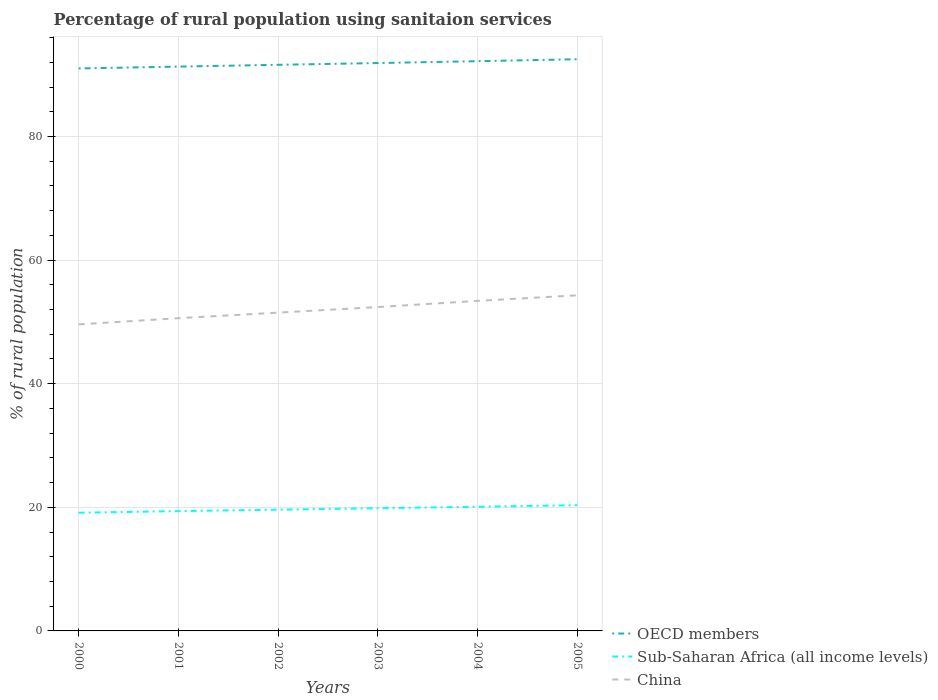How many different coloured lines are there?
Make the answer very short. 3. Does the line corresponding to Sub-Saharan Africa (all income levels) intersect with the line corresponding to OECD members?
Your answer should be very brief. No. Is the number of lines equal to the number of legend labels?
Offer a very short reply. Yes. Across all years, what is the maximum percentage of rural population using sanitaion services in OECD members?
Offer a terse response. 91.01. What is the total percentage of rural population using sanitaion services in OECD members in the graph?
Offer a terse response. -1.19. What is the difference between the highest and the second highest percentage of rural population using sanitaion services in OECD members?
Give a very brief answer. 1.48. What is the difference between the highest and the lowest percentage of rural population using sanitaion services in China?
Give a very brief answer. 3. Is the percentage of rural population using sanitaion services in OECD members strictly greater than the percentage of rural population using sanitaion services in Sub-Saharan Africa (all income levels) over the years?
Your answer should be very brief. No. How many lines are there?
Ensure brevity in your answer.  3. How many years are there in the graph?
Keep it short and to the point. 6. Are the values on the major ticks of Y-axis written in scientific E-notation?
Provide a succinct answer. No. How many legend labels are there?
Provide a succinct answer. 3. What is the title of the graph?
Offer a very short reply. Percentage of rural population using sanitaion services. Does "French Polynesia" appear as one of the legend labels in the graph?
Keep it short and to the point. No. What is the label or title of the Y-axis?
Your response must be concise. % of rural population. What is the % of rural population of OECD members in 2000?
Offer a terse response. 91.01. What is the % of rural population in Sub-Saharan Africa (all income levels) in 2000?
Provide a succinct answer. 19.13. What is the % of rural population of China in 2000?
Your answer should be very brief. 49.6. What is the % of rural population in OECD members in 2001?
Your response must be concise. 91.3. What is the % of rural population of Sub-Saharan Africa (all income levels) in 2001?
Keep it short and to the point. 19.38. What is the % of rural population of China in 2001?
Make the answer very short. 50.6. What is the % of rural population in OECD members in 2002?
Your answer should be compact. 91.6. What is the % of rural population in Sub-Saharan Africa (all income levels) in 2002?
Your answer should be compact. 19.62. What is the % of rural population in China in 2002?
Provide a short and direct response. 51.5. What is the % of rural population of OECD members in 2003?
Offer a very short reply. 91.88. What is the % of rural population of Sub-Saharan Africa (all income levels) in 2003?
Ensure brevity in your answer.  19.85. What is the % of rural population of China in 2003?
Give a very brief answer. 52.4. What is the % of rural population of OECD members in 2004?
Give a very brief answer. 92.18. What is the % of rural population of Sub-Saharan Africa (all income levels) in 2004?
Keep it short and to the point. 20.09. What is the % of rural population in China in 2004?
Give a very brief answer. 53.4. What is the % of rural population of OECD members in 2005?
Give a very brief answer. 92.5. What is the % of rural population of Sub-Saharan Africa (all income levels) in 2005?
Keep it short and to the point. 20.35. What is the % of rural population in China in 2005?
Keep it short and to the point. 54.3. Across all years, what is the maximum % of rural population in OECD members?
Give a very brief answer. 92.5. Across all years, what is the maximum % of rural population of Sub-Saharan Africa (all income levels)?
Give a very brief answer. 20.35. Across all years, what is the maximum % of rural population of China?
Offer a terse response. 54.3. Across all years, what is the minimum % of rural population in OECD members?
Provide a succinct answer. 91.01. Across all years, what is the minimum % of rural population in Sub-Saharan Africa (all income levels)?
Your answer should be compact. 19.13. Across all years, what is the minimum % of rural population in China?
Ensure brevity in your answer.  49.6. What is the total % of rural population in OECD members in the graph?
Provide a succinct answer. 550.47. What is the total % of rural population of Sub-Saharan Africa (all income levels) in the graph?
Make the answer very short. 118.42. What is the total % of rural population of China in the graph?
Your answer should be compact. 311.8. What is the difference between the % of rural population in OECD members in 2000 and that in 2001?
Your response must be concise. -0.29. What is the difference between the % of rural population in Sub-Saharan Africa (all income levels) in 2000 and that in 2001?
Ensure brevity in your answer.  -0.26. What is the difference between the % of rural population of China in 2000 and that in 2001?
Offer a very short reply. -1. What is the difference between the % of rural population of OECD members in 2000 and that in 2002?
Provide a succinct answer. -0.59. What is the difference between the % of rural population in Sub-Saharan Africa (all income levels) in 2000 and that in 2002?
Offer a very short reply. -0.49. What is the difference between the % of rural population in OECD members in 2000 and that in 2003?
Provide a succinct answer. -0.87. What is the difference between the % of rural population of Sub-Saharan Africa (all income levels) in 2000 and that in 2003?
Your answer should be compact. -0.72. What is the difference between the % of rural population of OECD members in 2000 and that in 2004?
Your answer should be compact. -1.17. What is the difference between the % of rural population in Sub-Saharan Africa (all income levels) in 2000 and that in 2004?
Give a very brief answer. -0.96. What is the difference between the % of rural population of OECD members in 2000 and that in 2005?
Ensure brevity in your answer.  -1.48. What is the difference between the % of rural population in Sub-Saharan Africa (all income levels) in 2000 and that in 2005?
Your response must be concise. -1.22. What is the difference between the % of rural population in OECD members in 2001 and that in 2002?
Ensure brevity in your answer.  -0.29. What is the difference between the % of rural population of Sub-Saharan Africa (all income levels) in 2001 and that in 2002?
Your response must be concise. -0.23. What is the difference between the % of rural population of China in 2001 and that in 2002?
Your answer should be very brief. -0.9. What is the difference between the % of rural population in OECD members in 2001 and that in 2003?
Offer a very short reply. -0.58. What is the difference between the % of rural population in Sub-Saharan Africa (all income levels) in 2001 and that in 2003?
Give a very brief answer. -0.47. What is the difference between the % of rural population of China in 2001 and that in 2003?
Your answer should be compact. -1.8. What is the difference between the % of rural population in OECD members in 2001 and that in 2004?
Offer a very short reply. -0.88. What is the difference between the % of rural population in Sub-Saharan Africa (all income levels) in 2001 and that in 2004?
Make the answer very short. -0.71. What is the difference between the % of rural population in China in 2001 and that in 2004?
Provide a short and direct response. -2.8. What is the difference between the % of rural population in OECD members in 2001 and that in 2005?
Your answer should be very brief. -1.19. What is the difference between the % of rural population in Sub-Saharan Africa (all income levels) in 2001 and that in 2005?
Offer a terse response. -0.96. What is the difference between the % of rural population of OECD members in 2002 and that in 2003?
Offer a very short reply. -0.28. What is the difference between the % of rural population of Sub-Saharan Africa (all income levels) in 2002 and that in 2003?
Provide a succinct answer. -0.23. What is the difference between the % of rural population in China in 2002 and that in 2003?
Your answer should be compact. -0.9. What is the difference between the % of rural population in OECD members in 2002 and that in 2004?
Your response must be concise. -0.58. What is the difference between the % of rural population of Sub-Saharan Africa (all income levels) in 2002 and that in 2004?
Your answer should be very brief. -0.47. What is the difference between the % of rural population of China in 2002 and that in 2004?
Your answer should be very brief. -1.9. What is the difference between the % of rural population in OECD members in 2002 and that in 2005?
Make the answer very short. -0.9. What is the difference between the % of rural population of Sub-Saharan Africa (all income levels) in 2002 and that in 2005?
Provide a short and direct response. -0.73. What is the difference between the % of rural population of OECD members in 2003 and that in 2004?
Your answer should be very brief. -0.3. What is the difference between the % of rural population in Sub-Saharan Africa (all income levels) in 2003 and that in 2004?
Provide a short and direct response. -0.24. What is the difference between the % of rural population in OECD members in 2003 and that in 2005?
Make the answer very short. -0.62. What is the difference between the % of rural population of Sub-Saharan Africa (all income levels) in 2003 and that in 2005?
Provide a succinct answer. -0.5. What is the difference between the % of rural population of OECD members in 2004 and that in 2005?
Your answer should be compact. -0.32. What is the difference between the % of rural population of Sub-Saharan Africa (all income levels) in 2004 and that in 2005?
Offer a terse response. -0.25. What is the difference between the % of rural population in China in 2004 and that in 2005?
Your response must be concise. -0.9. What is the difference between the % of rural population in OECD members in 2000 and the % of rural population in Sub-Saharan Africa (all income levels) in 2001?
Your answer should be compact. 71.63. What is the difference between the % of rural population in OECD members in 2000 and the % of rural population in China in 2001?
Ensure brevity in your answer.  40.41. What is the difference between the % of rural population in Sub-Saharan Africa (all income levels) in 2000 and the % of rural population in China in 2001?
Make the answer very short. -31.47. What is the difference between the % of rural population in OECD members in 2000 and the % of rural population in Sub-Saharan Africa (all income levels) in 2002?
Make the answer very short. 71.39. What is the difference between the % of rural population in OECD members in 2000 and the % of rural population in China in 2002?
Provide a short and direct response. 39.51. What is the difference between the % of rural population in Sub-Saharan Africa (all income levels) in 2000 and the % of rural population in China in 2002?
Ensure brevity in your answer.  -32.37. What is the difference between the % of rural population in OECD members in 2000 and the % of rural population in Sub-Saharan Africa (all income levels) in 2003?
Your response must be concise. 71.16. What is the difference between the % of rural population in OECD members in 2000 and the % of rural population in China in 2003?
Ensure brevity in your answer.  38.61. What is the difference between the % of rural population in Sub-Saharan Africa (all income levels) in 2000 and the % of rural population in China in 2003?
Provide a succinct answer. -33.27. What is the difference between the % of rural population of OECD members in 2000 and the % of rural population of Sub-Saharan Africa (all income levels) in 2004?
Ensure brevity in your answer.  70.92. What is the difference between the % of rural population in OECD members in 2000 and the % of rural population in China in 2004?
Your answer should be compact. 37.61. What is the difference between the % of rural population in Sub-Saharan Africa (all income levels) in 2000 and the % of rural population in China in 2004?
Your response must be concise. -34.27. What is the difference between the % of rural population of OECD members in 2000 and the % of rural population of Sub-Saharan Africa (all income levels) in 2005?
Offer a very short reply. 70.66. What is the difference between the % of rural population of OECD members in 2000 and the % of rural population of China in 2005?
Make the answer very short. 36.71. What is the difference between the % of rural population of Sub-Saharan Africa (all income levels) in 2000 and the % of rural population of China in 2005?
Give a very brief answer. -35.17. What is the difference between the % of rural population of OECD members in 2001 and the % of rural population of Sub-Saharan Africa (all income levels) in 2002?
Ensure brevity in your answer.  71.69. What is the difference between the % of rural population of OECD members in 2001 and the % of rural population of China in 2002?
Make the answer very short. 39.8. What is the difference between the % of rural population of Sub-Saharan Africa (all income levels) in 2001 and the % of rural population of China in 2002?
Offer a very short reply. -32.12. What is the difference between the % of rural population in OECD members in 2001 and the % of rural population in Sub-Saharan Africa (all income levels) in 2003?
Your response must be concise. 71.45. What is the difference between the % of rural population in OECD members in 2001 and the % of rural population in China in 2003?
Ensure brevity in your answer.  38.9. What is the difference between the % of rural population in Sub-Saharan Africa (all income levels) in 2001 and the % of rural population in China in 2003?
Ensure brevity in your answer.  -33.02. What is the difference between the % of rural population of OECD members in 2001 and the % of rural population of Sub-Saharan Africa (all income levels) in 2004?
Make the answer very short. 71.21. What is the difference between the % of rural population in OECD members in 2001 and the % of rural population in China in 2004?
Ensure brevity in your answer.  37.9. What is the difference between the % of rural population in Sub-Saharan Africa (all income levels) in 2001 and the % of rural population in China in 2004?
Give a very brief answer. -34.02. What is the difference between the % of rural population in OECD members in 2001 and the % of rural population in Sub-Saharan Africa (all income levels) in 2005?
Keep it short and to the point. 70.96. What is the difference between the % of rural population in OECD members in 2001 and the % of rural population in China in 2005?
Your answer should be very brief. 37. What is the difference between the % of rural population of Sub-Saharan Africa (all income levels) in 2001 and the % of rural population of China in 2005?
Make the answer very short. -34.92. What is the difference between the % of rural population of OECD members in 2002 and the % of rural population of Sub-Saharan Africa (all income levels) in 2003?
Offer a terse response. 71.75. What is the difference between the % of rural population in OECD members in 2002 and the % of rural population in China in 2003?
Offer a very short reply. 39.2. What is the difference between the % of rural population of Sub-Saharan Africa (all income levels) in 2002 and the % of rural population of China in 2003?
Provide a short and direct response. -32.78. What is the difference between the % of rural population in OECD members in 2002 and the % of rural population in Sub-Saharan Africa (all income levels) in 2004?
Give a very brief answer. 71.51. What is the difference between the % of rural population of OECD members in 2002 and the % of rural population of China in 2004?
Make the answer very short. 38.2. What is the difference between the % of rural population of Sub-Saharan Africa (all income levels) in 2002 and the % of rural population of China in 2004?
Give a very brief answer. -33.78. What is the difference between the % of rural population of OECD members in 2002 and the % of rural population of Sub-Saharan Africa (all income levels) in 2005?
Offer a very short reply. 71.25. What is the difference between the % of rural population of OECD members in 2002 and the % of rural population of China in 2005?
Ensure brevity in your answer.  37.3. What is the difference between the % of rural population of Sub-Saharan Africa (all income levels) in 2002 and the % of rural population of China in 2005?
Make the answer very short. -34.68. What is the difference between the % of rural population of OECD members in 2003 and the % of rural population of Sub-Saharan Africa (all income levels) in 2004?
Offer a very short reply. 71.79. What is the difference between the % of rural population of OECD members in 2003 and the % of rural population of China in 2004?
Your answer should be very brief. 38.48. What is the difference between the % of rural population of Sub-Saharan Africa (all income levels) in 2003 and the % of rural population of China in 2004?
Your answer should be very brief. -33.55. What is the difference between the % of rural population in OECD members in 2003 and the % of rural population in Sub-Saharan Africa (all income levels) in 2005?
Your answer should be compact. 71.53. What is the difference between the % of rural population in OECD members in 2003 and the % of rural population in China in 2005?
Give a very brief answer. 37.58. What is the difference between the % of rural population in Sub-Saharan Africa (all income levels) in 2003 and the % of rural population in China in 2005?
Make the answer very short. -34.45. What is the difference between the % of rural population in OECD members in 2004 and the % of rural population in Sub-Saharan Africa (all income levels) in 2005?
Provide a short and direct response. 71.83. What is the difference between the % of rural population in OECD members in 2004 and the % of rural population in China in 2005?
Provide a short and direct response. 37.88. What is the difference between the % of rural population in Sub-Saharan Africa (all income levels) in 2004 and the % of rural population in China in 2005?
Offer a very short reply. -34.21. What is the average % of rural population in OECD members per year?
Provide a succinct answer. 91.74. What is the average % of rural population of Sub-Saharan Africa (all income levels) per year?
Your answer should be very brief. 19.74. What is the average % of rural population in China per year?
Keep it short and to the point. 51.97. In the year 2000, what is the difference between the % of rural population in OECD members and % of rural population in Sub-Saharan Africa (all income levels)?
Provide a succinct answer. 71.88. In the year 2000, what is the difference between the % of rural population of OECD members and % of rural population of China?
Keep it short and to the point. 41.41. In the year 2000, what is the difference between the % of rural population of Sub-Saharan Africa (all income levels) and % of rural population of China?
Make the answer very short. -30.47. In the year 2001, what is the difference between the % of rural population in OECD members and % of rural population in Sub-Saharan Africa (all income levels)?
Offer a terse response. 71.92. In the year 2001, what is the difference between the % of rural population in OECD members and % of rural population in China?
Provide a short and direct response. 40.7. In the year 2001, what is the difference between the % of rural population of Sub-Saharan Africa (all income levels) and % of rural population of China?
Give a very brief answer. -31.22. In the year 2002, what is the difference between the % of rural population in OECD members and % of rural population in Sub-Saharan Africa (all income levels)?
Keep it short and to the point. 71.98. In the year 2002, what is the difference between the % of rural population in OECD members and % of rural population in China?
Keep it short and to the point. 40.1. In the year 2002, what is the difference between the % of rural population of Sub-Saharan Africa (all income levels) and % of rural population of China?
Provide a succinct answer. -31.88. In the year 2003, what is the difference between the % of rural population of OECD members and % of rural population of Sub-Saharan Africa (all income levels)?
Offer a very short reply. 72.03. In the year 2003, what is the difference between the % of rural population in OECD members and % of rural population in China?
Offer a very short reply. 39.48. In the year 2003, what is the difference between the % of rural population of Sub-Saharan Africa (all income levels) and % of rural population of China?
Give a very brief answer. -32.55. In the year 2004, what is the difference between the % of rural population of OECD members and % of rural population of Sub-Saharan Africa (all income levels)?
Your answer should be very brief. 72.09. In the year 2004, what is the difference between the % of rural population in OECD members and % of rural population in China?
Your answer should be compact. 38.78. In the year 2004, what is the difference between the % of rural population of Sub-Saharan Africa (all income levels) and % of rural population of China?
Offer a very short reply. -33.31. In the year 2005, what is the difference between the % of rural population of OECD members and % of rural population of Sub-Saharan Africa (all income levels)?
Make the answer very short. 72.15. In the year 2005, what is the difference between the % of rural population of OECD members and % of rural population of China?
Offer a terse response. 38.2. In the year 2005, what is the difference between the % of rural population in Sub-Saharan Africa (all income levels) and % of rural population in China?
Keep it short and to the point. -33.95. What is the ratio of the % of rural population in OECD members in 2000 to that in 2001?
Give a very brief answer. 1. What is the ratio of the % of rural population in Sub-Saharan Africa (all income levels) in 2000 to that in 2001?
Ensure brevity in your answer.  0.99. What is the ratio of the % of rural population in China in 2000 to that in 2001?
Ensure brevity in your answer.  0.98. What is the ratio of the % of rural population in OECD members in 2000 to that in 2002?
Your answer should be very brief. 0.99. What is the ratio of the % of rural population in Sub-Saharan Africa (all income levels) in 2000 to that in 2002?
Keep it short and to the point. 0.97. What is the ratio of the % of rural population in China in 2000 to that in 2002?
Ensure brevity in your answer.  0.96. What is the ratio of the % of rural population in Sub-Saharan Africa (all income levels) in 2000 to that in 2003?
Your answer should be compact. 0.96. What is the ratio of the % of rural population in China in 2000 to that in 2003?
Your response must be concise. 0.95. What is the ratio of the % of rural population in OECD members in 2000 to that in 2004?
Your answer should be very brief. 0.99. What is the ratio of the % of rural population of China in 2000 to that in 2004?
Offer a very short reply. 0.93. What is the ratio of the % of rural population in OECD members in 2000 to that in 2005?
Ensure brevity in your answer.  0.98. What is the ratio of the % of rural population in Sub-Saharan Africa (all income levels) in 2000 to that in 2005?
Provide a succinct answer. 0.94. What is the ratio of the % of rural population of China in 2000 to that in 2005?
Keep it short and to the point. 0.91. What is the ratio of the % of rural population in Sub-Saharan Africa (all income levels) in 2001 to that in 2002?
Your response must be concise. 0.99. What is the ratio of the % of rural population in China in 2001 to that in 2002?
Keep it short and to the point. 0.98. What is the ratio of the % of rural population in Sub-Saharan Africa (all income levels) in 2001 to that in 2003?
Provide a short and direct response. 0.98. What is the ratio of the % of rural population in China in 2001 to that in 2003?
Keep it short and to the point. 0.97. What is the ratio of the % of rural population in OECD members in 2001 to that in 2004?
Give a very brief answer. 0.99. What is the ratio of the % of rural population of Sub-Saharan Africa (all income levels) in 2001 to that in 2004?
Offer a very short reply. 0.96. What is the ratio of the % of rural population of China in 2001 to that in 2004?
Keep it short and to the point. 0.95. What is the ratio of the % of rural population of OECD members in 2001 to that in 2005?
Your answer should be compact. 0.99. What is the ratio of the % of rural population of Sub-Saharan Africa (all income levels) in 2001 to that in 2005?
Give a very brief answer. 0.95. What is the ratio of the % of rural population in China in 2001 to that in 2005?
Offer a very short reply. 0.93. What is the ratio of the % of rural population in Sub-Saharan Africa (all income levels) in 2002 to that in 2003?
Your answer should be very brief. 0.99. What is the ratio of the % of rural population in China in 2002 to that in 2003?
Your answer should be very brief. 0.98. What is the ratio of the % of rural population in Sub-Saharan Africa (all income levels) in 2002 to that in 2004?
Give a very brief answer. 0.98. What is the ratio of the % of rural population of China in 2002 to that in 2004?
Keep it short and to the point. 0.96. What is the ratio of the % of rural population in OECD members in 2002 to that in 2005?
Ensure brevity in your answer.  0.99. What is the ratio of the % of rural population in Sub-Saharan Africa (all income levels) in 2002 to that in 2005?
Offer a very short reply. 0.96. What is the ratio of the % of rural population in China in 2002 to that in 2005?
Keep it short and to the point. 0.95. What is the ratio of the % of rural population in China in 2003 to that in 2004?
Your answer should be compact. 0.98. What is the ratio of the % of rural population in OECD members in 2003 to that in 2005?
Ensure brevity in your answer.  0.99. What is the ratio of the % of rural population of Sub-Saharan Africa (all income levels) in 2003 to that in 2005?
Make the answer very short. 0.98. What is the ratio of the % of rural population in Sub-Saharan Africa (all income levels) in 2004 to that in 2005?
Provide a succinct answer. 0.99. What is the ratio of the % of rural population of China in 2004 to that in 2005?
Keep it short and to the point. 0.98. What is the difference between the highest and the second highest % of rural population of OECD members?
Provide a succinct answer. 0.32. What is the difference between the highest and the second highest % of rural population in Sub-Saharan Africa (all income levels)?
Offer a terse response. 0.25. What is the difference between the highest and the second highest % of rural population in China?
Give a very brief answer. 0.9. What is the difference between the highest and the lowest % of rural population of OECD members?
Offer a very short reply. 1.48. What is the difference between the highest and the lowest % of rural population in Sub-Saharan Africa (all income levels)?
Your response must be concise. 1.22. 